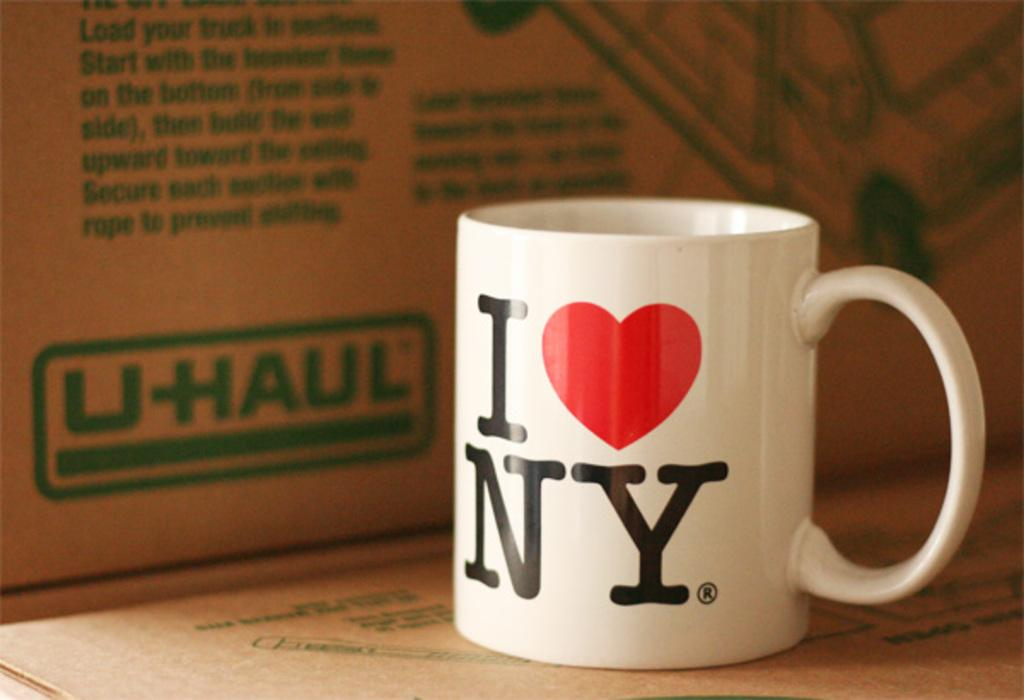<image>
Relay a brief, clear account of the picture shown. Love New York ceramic mug sitting in front of a U-Haul cardboard box. 